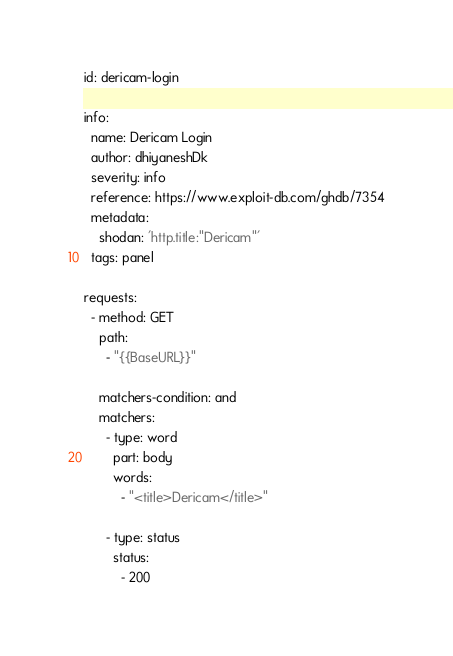<code> <loc_0><loc_0><loc_500><loc_500><_YAML_>id: dericam-login

info:
  name: Dericam Login
  author: dhiyaneshDk
  severity: info
  reference: https://www.exploit-db.com/ghdb/7354
  metadata:
    shodan: 'http.title:"Dericam"'
  tags: panel

requests:
  - method: GET
    path:
      - "{{BaseURL}}"

    matchers-condition: and
    matchers:
      - type: word
        part: body
        words:
          - "<title>Dericam</title>"

      - type: status
        status:
          - 200
</code> 